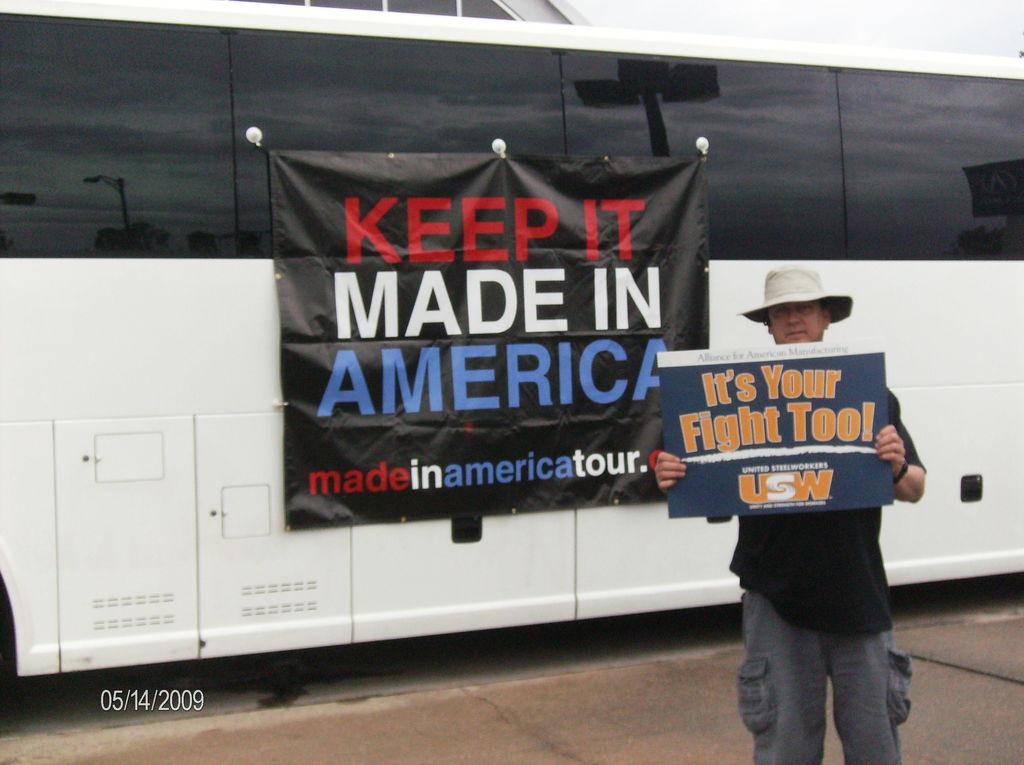What is the man in the image doing? The man is standing in the image and holding an advertisement. Can you describe the advertisement the man is holding? Unfortunately, the details of the advertisement cannot be determined from the image. What can be seen in the background of the image? There is a motor vehicle in the background of the image. What is on the motor vehicle in the image? An advertisement is hanged on the motor vehicle. How does the man's breath affect the advertisement he is holding? There is no information about the man's breath in the image, and therefore its effect on the advertisement cannot be determined. 